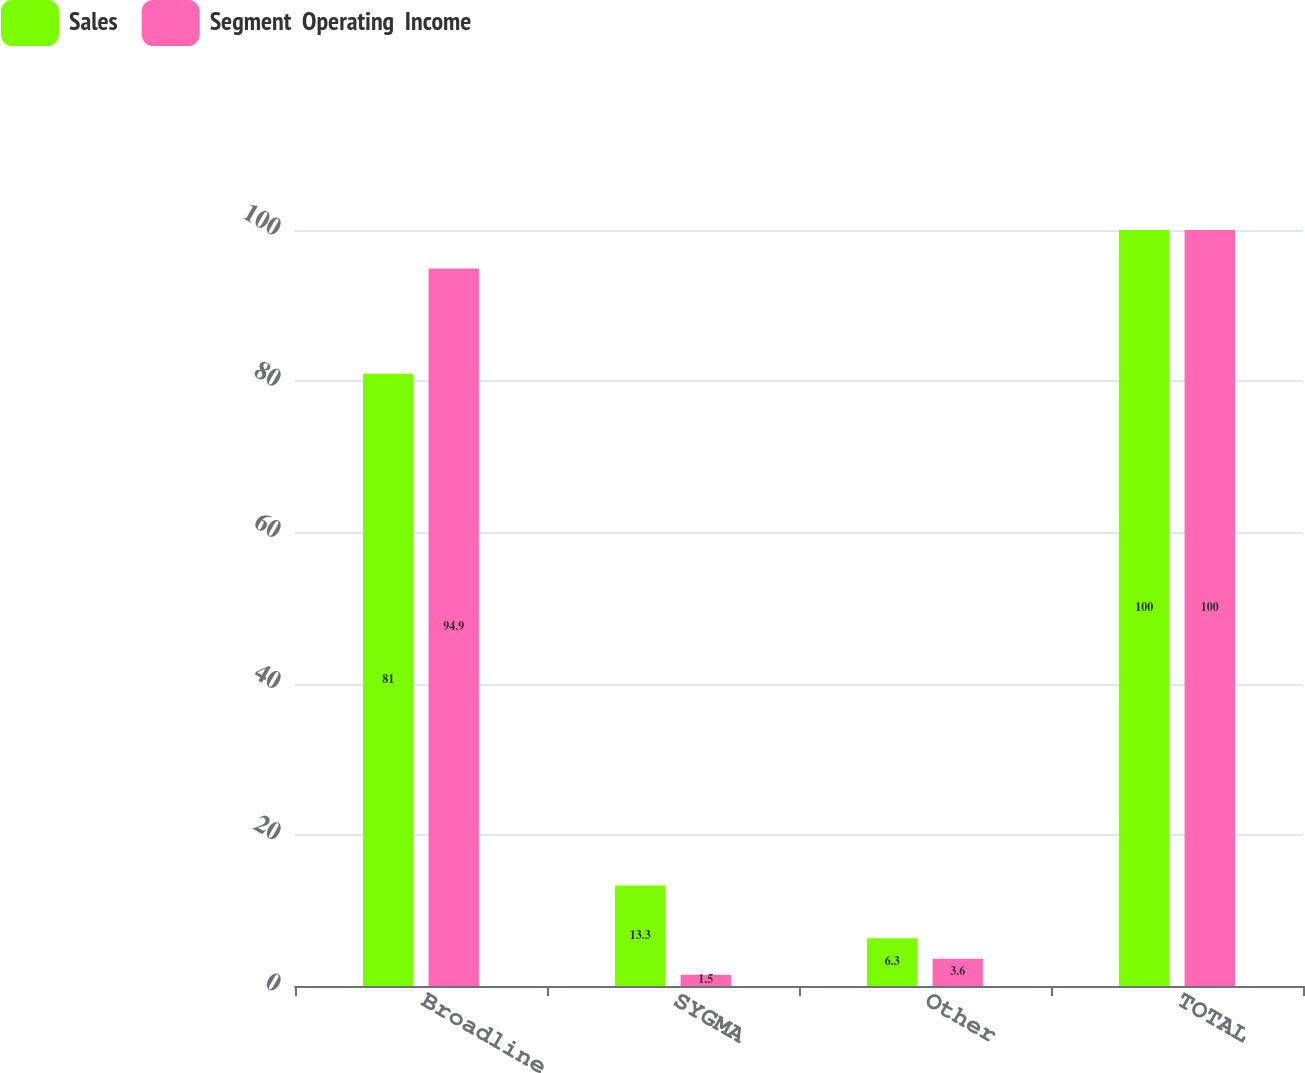<chart> <loc_0><loc_0><loc_500><loc_500><stacked_bar_chart><ecel><fcel>Broadline<fcel>SYGMA<fcel>Other<fcel>TOTAL<nl><fcel>Sales<fcel>81<fcel>13.3<fcel>6.3<fcel>100<nl><fcel>Segment  Operating  Income<fcel>94.9<fcel>1.5<fcel>3.6<fcel>100<nl></chart> 